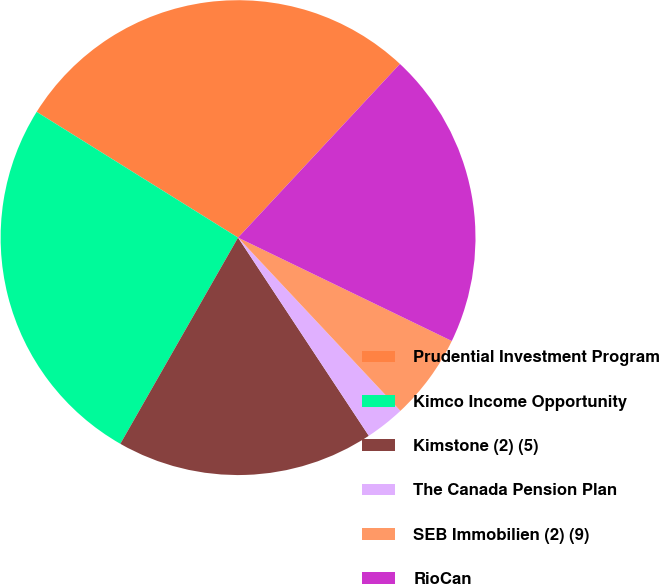<chart> <loc_0><loc_0><loc_500><loc_500><pie_chart><fcel>Prudential Investment Program<fcel>Kimco Income Opportunity<fcel>Kimstone (2) (5)<fcel>The Canada Pension Plan<fcel>SEB Immobilien (2) (9)<fcel>RioCan<nl><fcel>28.06%<fcel>25.63%<fcel>17.54%<fcel>2.7%<fcel>5.85%<fcel>20.23%<nl></chart> 